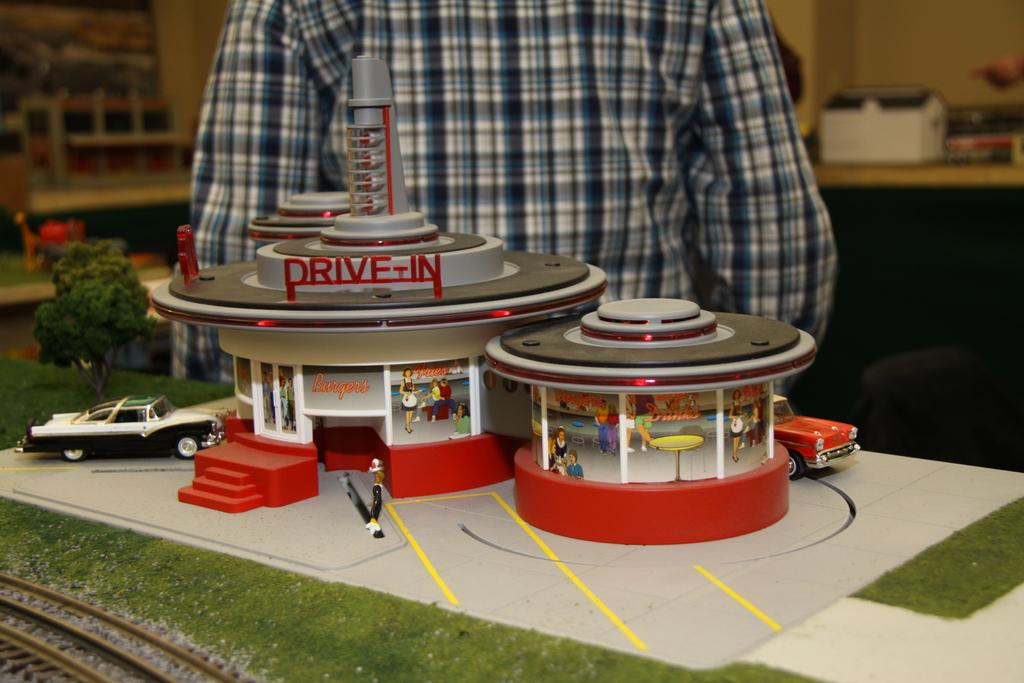<image>
Render a clear and concise summary of the photo. A model toy for a Drive In restaurant is displayed on a table 